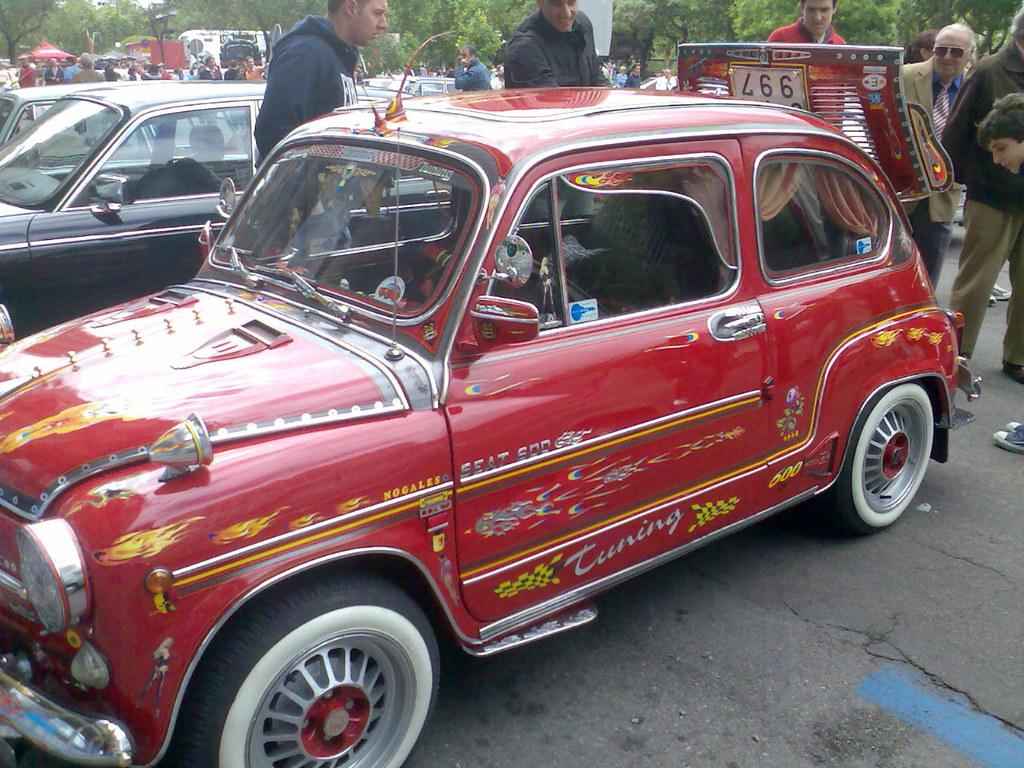<image>
Present a compact description of the photo's key features. the word tuning that is on a car 